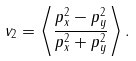<formula> <loc_0><loc_0><loc_500><loc_500>v _ { 2 } = \left \langle \frac { p _ { x } ^ { 2 } - p _ { y } ^ { 2 } } { p _ { x } ^ { 2 } + p _ { y } ^ { 2 } } \right \rangle .</formula> 